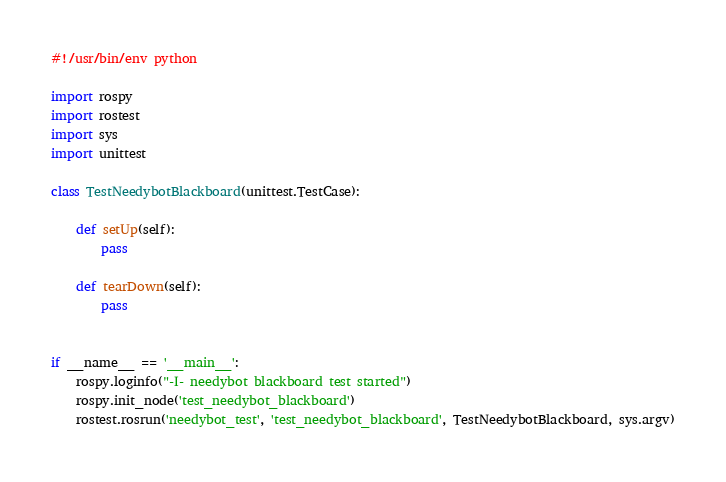Convert code to text. <code><loc_0><loc_0><loc_500><loc_500><_Python_>#!/usr/bin/env python

import rospy
import rostest
import sys
import unittest

class TestNeedybotBlackboard(unittest.TestCase): 

    def setUp(self):
        pass

    def tearDown(self):
        pass


if __name__ == '__main__':
    rospy.loginfo("-I- needybot blackboard test started")
    rospy.init_node('test_needybot_blackboard')
    rostest.rosrun('needybot_test', 'test_needybot_blackboard', TestNeedybotBlackboard, sys.argv)
</code> 